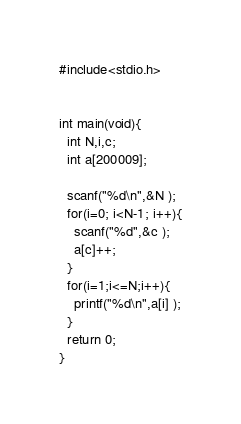Convert code to text. <code><loc_0><loc_0><loc_500><loc_500><_C_>#include<stdio.h>


int main(void){
  int N,i,c;
  int a[200009];

  scanf("%d\n",&N );
  for(i=0; i<N-1; i++){
    scanf("%d",&c );
    a[c]++;
  }
  for(i=1;i<=N;i++){
    printf("%d\n",a[i] );
  }
  return 0;
}</code> 